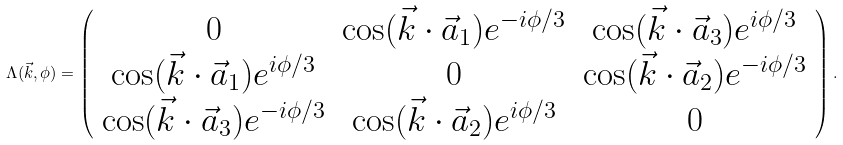Convert formula to latex. <formula><loc_0><loc_0><loc_500><loc_500>\Lambda ( \vec { k } , \phi ) = \left ( \begin{array} { c c c } 0 & \cos ( \vec { k } \cdot \vec { a } _ { 1 } ) e ^ { - i \phi / 3 } & \cos ( \vec { k } \cdot \vec { a } _ { 3 } ) e ^ { i \phi / 3 } \\ \cos ( \vec { k } \cdot \vec { a } _ { 1 } ) e ^ { i \phi / 3 } & 0 & \cos ( \vec { k } \cdot \vec { a } _ { 2 } ) e ^ { - i \phi / 3 } \\ \cos ( \vec { k } \cdot \vec { a } _ { 3 } ) e ^ { - i \phi / 3 } & \cos ( \vec { k } \cdot \vec { a } _ { 2 } ) e ^ { i \phi / 3 } & 0 \end{array} \right ) .</formula> 